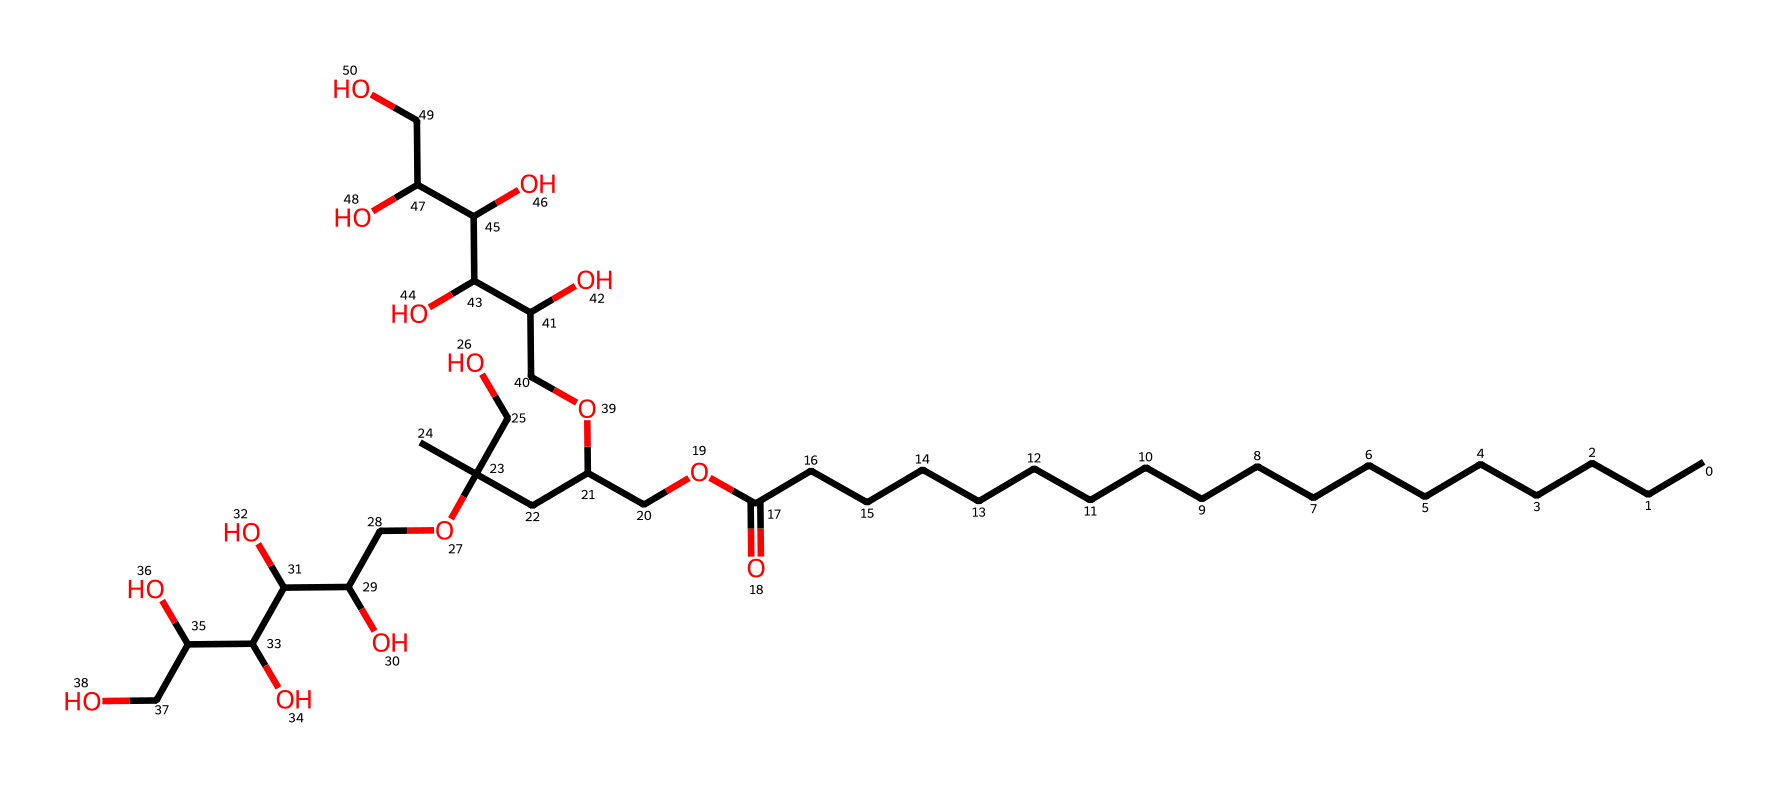What is the total number of carbon atoms in this chemical? By examining the SMILES representation, we count the 'C' symbols, which indicate carbon atoms. The main linear chain consists of 18 carbon atoms, and through the second part of the structure denoted by additional 'C's connected by oxygen, we find 5 more carbon atoms. Adding these results gives a total of 23 carbon atoms.
Answer: 23 How many hydroxyl (–OH) groups are present in this chemical? The hydroxyl groups are indicated by the presence of ‘O’ connected to ‘C’ with hydrogen atoms in the molecular structure. In the given SMILES, we observe several occurrences of ‘O’ directly connected to ‘C’ with implied hydrogens, totaling 6 instances of this configuration.
Answer: 6 Which part of this chemical structure makes it a surfactant? Surfactants generally possess a hydrophilic (water-attracting) and a hydrophobic (water-repelling) portion. In the SMILES, the long carbon chain exhibits hydrophobic characteristics, while the multiple hydroxyl groups and ether functionalities provide hydrophilic properties, confirming its surfactant nature.
Answer: hydrophilic and hydrophobic portions What is the function of polysorbate 20 in food products? Polysorbate 20 acts as an emulsifier in food products, stabilizing mixtures of oil and water. The balance between its hydrophilic and hydrophobic parts allows it to reduce surface tension and improve the mixing of ingredients in emulsified products.
Answer: emulsifier How does the presence of the carbon chain influence the emulsifying properties of polysorbate 20? The long carbon chain provides hydrophobic characteristics, allowing the polysorbate to interact with oil, while the hydrophilic groups stabilize the mixture in water. This dual nature is crucial for emulsification, enhancing the stability of food products.
Answer: enhances emulsification stability 